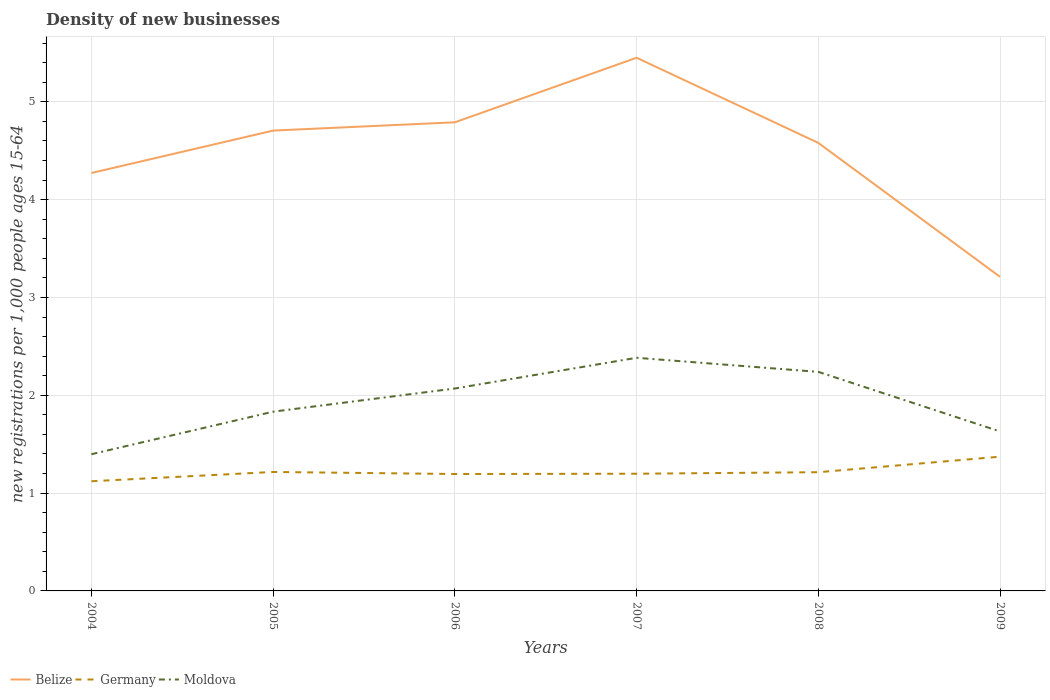Does the line corresponding to Belize intersect with the line corresponding to Moldova?
Your response must be concise. No. Across all years, what is the maximum number of new registrations in Germany?
Your response must be concise. 1.12. What is the total number of new registrations in Moldova in the graph?
Keep it short and to the point. -0.23. What is the difference between the highest and the second highest number of new registrations in Germany?
Offer a terse response. 0.25. Is the number of new registrations in Germany strictly greater than the number of new registrations in Belize over the years?
Your answer should be compact. Yes. How many lines are there?
Offer a very short reply. 3. How many years are there in the graph?
Provide a succinct answer. 6. What is the difference between two consecutive major ticks on the Y-axis?
Offer a very short reply. 1. Does the graph contain grids?
Make the answer very short. Yes. Where does the legend appear in the graph?
Provide a short and direct response. Bottom left. How many legend labels are there?
Your answer should be compact. 3. What is the title of the graph?
Give a very brief answer. Density of new businesses. Does "Mongolia" appear as one of the legend labels in the graph?
Provide a succinct answer. No. What is the label or title of the X-axis?
Your answer should be compact. Years. What is the label or title of the Y-axis?
Give a very brief answer. New registrations per 1,0 people ages 15-64. What is the new registrations per 1,000 people ages 15-64 of Belize in 2004?
Your response must be concise. 4.27. What is the new registrations per 1,000 people ages 15-64 in Germany in 2004?
Your answer should be compact. 1.12. What is the new registrations per 1,000 people ages 15-64 in Moldova in 2004?
Offer a terse response. 1.4. What is the new registrations per 1,000 people ages 15-64 of Belize in 2005?
Your response must be concise. 4.71. What is the new registrations per 1,000 people ages 15-64 of Germany in 2005?
Provide a short and direct response. 1.22. What is the new registrations per 1,000 people ages 15-64 of Moldova in 2005?
Offer a very short reply. 1.83. What is the new registrations per 1,000 people ages 15-64 of Belize in 2006?
Offer a very short reply. 4.79. What is the new registrations per 1,000 people ages 15-64 in Germany in 2006?
Your response must be concise. 1.2. What is the new registrations per 1,000 people ages 15-64 in Moldova in 2006?
Ensure brevity in your answer.  2.07. What is the new registrations per 1,000 people ages 15-64 of Belize in 2007?
Provide a succinct answer. 5.45. What is the new registrations per 1,000 people ages 15-64 of Germany in 2007?
Offer a terse response. 1.2. What is the new registrations per 1,000 people ages 15-64 in Moldova in 2007?
Provide a short and direct response. 2.38. What is the new registrations per 1,000 people ages 15-64 in Belize in 2008?
Ensure brevity in your answer.  4.58. What is the new registrations per 1,000 people ages 15-64 of Germany in 2008?
Give a very brief answer. 1.21. What is the new registrations per 1,000 people ages 15-64 of Moldova in 2008?
Your answer should be very brief. 2.24. What is the new registrations per 1,000 people ages 15-64 in Belize in 2009?
Your answer should be compact. 3.21. What is the new registrations per 1,000 people ages 15-64 in Germany in 2009?
Provide a succinct answer. 1.37. What is the new registrations per 1,000 people ages 15-64 of Moldova in 2009?
Your answer should be compact. 1.63. Across all years, what is the maximum new registrations per 1,000 people ages 15-64 of Belize?
Your answer should be compact. 5.45. Across all years, what is the maximum new registrations per 1,000 people ages 15-64 in Germany?
Make the answer very short. 1.37. Across all years, what is the maximum new registrations per 1,000 people ages 15-64 of Moldova?
Give a very brief answer. 2.38. Across all years, what is the minimum new registrations per 1,000 people ages 15-64 of Belize?
Make the answer very short. 3.21. Across all years, what is the minimum new registrations per 1,000 people ages 15-64 in Germany?
Ensure brevity in your answer.  1.12. Across all years, what is the minimum new registrations per 1,000 people ages 15-64 of Moldova?
Your answer should be very brief. 1.4. What is the total new registrations per 1,000 people ages 15-64 of Belize in the graph?
Keep it short and to the point. 27.01. What is the total new registrations per 1,000 people ages 15-64 of Germany in the graph?
Your answer should be very brief. 7.32. What is the total new registrations per 1,000 people ages 15-64 of Moldova in the graph?
Ensure brevity in your answer.  11.55. What is the difference between the new registrations per 1,000 people ages 15-64 of Belize in 2004 and that in 2005?
Keep it short and to the point. -0.43. What is the difference between the new registrations per 1,000 people ages 15-64 of Germany in 2004 and that in 2005?
Provide a succinct answer. -0.09. What is the difference between the new registrations per 1,000 people ages 15-64 of Moldova in 2004 and that in 2005?
Your response must be concise. -0.43. What is the difference between the new registrations per 1,000 people ages 15-64 of Belize in 2004 and that in 2006?
Give a very brief answer. -0.52. What is the difference between the new registrations per 1,000 people ages 15-64 of Germany in 2004 and that in 2006?
Give a very brief answer. -0.07. What is the difference between the new registrations per 1,000 people ages 15-64 in Moldova in 2004 and that in 2006?
Ensure brevity in your answer.  -0.67. What is the difference between the new registrations per 1,000 people ages 15-64 of Belize in 2004 and that in 2007?
Ensure brevity in your answer.  -1.18. What is the difference between the new registrations per 1,000 people ages 15-64 in Germany in 2004 and that in 2007?
Offer a very short reply. -0.08. What is the difference between the new registrations per 1,000 people ages 15-64 of Moldova in 2004 and that in 2007?
Your answer should be very brief. -0.99. What is the difference between the new registrations per 1,000 people ages 15-64 of Belize in 2004 and that in 2008?
Your answer should be very brief. -0.31. What is the difference between the new registrations per 1,000 people ages 15-64 of Germany in 2004 and that in 2008?
Your answer should be compact. -0.09. What is the difference between the new registrations per 1,000 people ages 15-64 in Moldova in 2004 and that in 2008?
Provide a succinct answer. -0.84. What is the difference between the new registrations per 1,000 people ages 15-64 of Belize in 2004 and that in 2009?
Give a very brief answer. 1.06. What is the difference between the new registrations per 1,000 people ages 15-64 in Germany in 2004 and that in 2009?
Give a very brief answer. -0.25. What is the difference between the new registrations per 1,000 people ages 15-64 in Moldova in 2004 and that in 2009?
Offer a very short reply. -0.23. What is the difference between the new registrations per 1,000 people ages 15-64 of Belize in 2005 and that in 2006?
Provide a succinct answer. -0.08. What is the difference between the new registrations per 1,000 people ages 15-64 in Germany in 2005 and that in 2006?
Provide a succinct answer. 0.02. What is the difference between the new registrations per 1,000 people ages 15-64 of Moldova in 2005 and that in 2006?
Your answer should be very brief. -0.24. What is the difference between the new registrations per 1,000 people ages 15-64 in Belize in 2005 and that in 2007?
Give a very brief answer. -0.74. What is the difference between the new registrations per 1,000 people ages 15-64 in Germany in 2005 and that in 2007?
Offer a very short reply. 0.02. What is the difference between the new registrations per 1,000 people ages 15-64 in Moldova in 2005 and that in 2007?
Ensure brevity in your answer.  -0.55. What is the difference between the new registrations per 1,000 people ages 15-64 of Belize in 2005 and that in 2008?
Provide a succinct answer. 0.13. What is the difference between the new registrations per 1,000 people ages 15-64 in Germany in 2005 and that in 2008?
Your answer should be compact. 0. What is the difference between the new registrations per 1,000 people ages 15-64 of Moldova in 2005 and that in 2008?
Provide a succinct answer. -0.41. What is the difference between the new registrations per 1,000 people ages 15-64 of Belize in 2005 and that in 2009?
Offer a very short reply. 1.5. What is the difference between the new registrations per 1,000 people ages 15-64 of Germany in 2005 and that in 2009?
Keep it short and to the point. -0.16. What is the difference between the new registrations per 1,000 people ages 15-64 of Moldova in 2005 and that in 2009?
Your answer should be compact. 0.2. What is the difference between the new registrations per 1,000 people ages 15-64 in Belize in 2006 and that in 2007?
Keep it short and to the point. -0.66. What is the difference between the new registrations per 1,000 people ages 15-64 in Germany in 2006 and that in 2007?
Your response must be concise. -0. What is the difference between the new registrations per 1,000 people ages 15-64 of Moldova in 2006 and that in 2007?
Keep it short and to the point. -0.31. What is the difference between the new registrations per 1,000 people ages 15-64 in Belize in 2006 and that in 2008?
Your response must be concise. 0.21. What is the difference between the new registrations per 1,000 people ages 15-64 of Germany in 2006 and that in 2008?
Your answer should be compact. -0.02. What is the difference between the new registrations per 1,000 people ages 15-64 in Moldova in 2006 and that in 2008?
Offer a terse response. -0.17. What is the difference between the new registrations per 1,000 people ages 15-64 in Belize in 2006 and that in 2009?
Ensure brevity in your answer.  1.58. What is the difference between the new registrations per 1,000 people ages 15-64 of Germany in 2006 and that in 2009?
Offer a terse response. -0.18. What is the difference between the new registrations per 1,000 people ages 15-64 in Moldova in 2006 and that in 2009?
Provide a succinct answer. 0.44. What is the difference between the new registrations per 1,000 people ages 15-64 of Belize in 2007 and that in 2008?
Ensure brevity in your answer.  0.87. What is the difference between the new registrations per 1,000 people ages 15-64 of Germany in 2007 and that in 2008?
Provide a short and direct response. -0.02. What is the difference between the new registrations per 1,000 people ages 15-64 of Moldova in 2007 and that in 2008?
Ensure brevity in your answer.  0.14. What is the difference between the new registrations per 1,000 people ages 15-64 of Belize in 2007 and that in 2009?
Your answer should be compact. 2.24. What is the difference between the new registrations per 1,000 people ages 15-64 in Germany in 2007 and that in 2009?
Give a very brief answer. -0.17. What is the difference between the new registrations per 1,000 people ages 15-64 in Moldova in 2007 and that in 2009?
Your answer should be compact. 0.75. What is the difference between the new registrations per 1,000 people ages 15-64 in Belize in 2008 and that in 2009?
Give a very brief answer. 1.37. What is the difference between the new registrations per 1,000 people ages 15-64 of Germany in 2008 and that in 2009?
Your answer should be compact. -0.16. What is the difference between the new registrations per 1,000 people ages 15-64 in Moldova in 2008 and that in 2009?
Provide a succinct answer. 0.61. What is the difference between the new registrations per 1,000 people ages 15-64 in Belize in 2004 and the new registrations per 1,000 people ages 15-64 in Germany in 2005?
Your response must be concise. 3.06. What is the difference between the new registrations per 1,000 people ages 15-64 in Belize in 2004 and the new registrations per 1,000 people ages 15-64 in Moldova in 2005?
Offer a very short reply. 2.44. What is the difference between the new registrations per 1,000 people ages 15-64 of Germany in 2004 and the new registrations per 1,000 people ages 15-64 of Moldova in 2005?
Your answer should be compact. -0.71. What is the difference between the new registrations per 1,000 people ages 15-64 in Belize in 2004 and the new registrations per 1,000 people ages 15-64 in Germany in 2006?
Your answer should be compact. 3.08. What is the difference between the new registrations per 1,000 people ages 15-64 of Belize in 2004 and the new registrations per 1,000 people ages 15-64 of Moldova in 2006?
Your answer should be very brief. 2.2. What is the difference between the new registrations per 1,000 people ages 15-64 in Germany in 2004 and the new registrations per 1,000 people ages 15-64 in Moldova in 2006?
Give a very brief answer. -0.95. What is the difference between the new registrations per 1,000 people ages 15-64 in Belize in 2004 and the new registrations per 1,000 people ages 15-64 in Germany in 2007?
Give a very brief answer. 3.07. What is the difference between the new registrations per 1,000 people ages 15-64 in Belize in 2004 and the new registrations per 1,000 people ages 15-64 in Moldova in 2007?
Provide a succinct answer. 1.89. What is the difference between the new registrations per 1,000 people ages 15-64 in Germany in 2004 and the new registrations per 1,000 people ages 15-64 in Moldova in 2007?
Offer a terse response. -1.26. What is the difference between the new registrations per 1,000 people ages 15-64 of Belize in 2004 and the new registrations per 1,000 people ages 15-64 of Germany in 2008?
Your answer should be compact. 3.06. What is the difference between the new registrations per 1,000 people ages 15-64 in Belize in 2004 and the new registrations per 1,000 people ages 15-64 in Moldova in 2008?
Make the answer very short. 2.03. What is the difference between the new registrations per 1,000 people ages 15-64 in Germany in 2004 and the new registrations per 1,000 people ages 15-64 in Moldova in 2008?
Your answer should be very brief. -1.12. What is the difference between the new registrations per 1,000 people ages 15-64 of Belize in 2004 and the new registrations per 1,000 people ages 15-64 of Germany in 2009?
Offer a very short reply. 2.9. What is the difference between the new registrations per 1,000 people ages 15-64 of Belize in 2004 and the new registrations per 1,000 people ages 15-64 of Moldova in 2009?
Give a very brief answer. 2.64. What is the difference between the new registrations per 1,000 people ages 15-64 of Germany in 2004 and the new registrations per 1,000 people ages 15-64 of Moldova in 2009?
Keep it short and to the point. -0.51. What is the difference between the new registrations per 1,000 people ages 15-64 in Belize in 2005 and the new registrations per 1,000 people ages 15-64 in Germany in 2006?
Give a very brief answer. 3.51. What is the difference between the new registrations per 1,000 people ages 15-64 of Belize in 2005 and the new registrations per 1,000 people ages 15-64 of Moldova in 2006?
Your answer should be very brief. 2.64. What is the difference between the new registrations per 1,000 people ages 15-64 of Germany in 2005 and the new registrations per 1,000 people ages 15-64 of Moldova in 2006?
Ensure brevity in your answer.  -0.85. What is the difference between the new registrations per 1,000 people ages 15-64 in Belize in 2005 and the new registrations per 1,000 people ages 15-64 in Germany in 2007?
Give a very brief answer. 3.51. What is the difference between the new registrations per 1,000 people ages 15-64 of Belize in 2005 and the new registrations per 1,000 people ages 15-64 of Moldova in 2007?
Give a very brief answer. 2.32. What is the difference between the new registrations per 1,000 people ages 15-64 of Germany in 2005 and the new registrations per 1,000 people ages 15-64 of Moldova in 2007?
Provide a short and direct response. -1.17. What is the difference between the new registrations per 1,000 people ages 15-64 in Belize in 2005 and the new registrations per 1,000 people ages 15-64 in Germany in 2008?
Give a very brief answer. 3.49. What is the difference between the new registrations per 1,000 people ages 15-64 in Belize in 2005 and the new registrations per 1,000 people ages 15-64 in Moldova in 2008?
Provide a short and direct response. 2.47. What is the difference between the new registrations per 1,000 people ages 15-64 of Germany in 2005 and the new registrations per 1,000 people ages 15-64 of Moldova in 2008?
Keep it short and to the point. -1.02. What is the difference between the new registrations per 1,000 people ages 15-64 in Belize in 2005 and the new registrations per 1,000 people ages 15-64 in Germany in 2009?
Provide a succinct answer. 3.33. What is the difference between the new registrations per 1,000 people ages 15-64 in Belize in 2005 and the new registrations per 1,000 people ages 15-64 in Moldova in 2009?
Provide a short and direct response. 3.08. What is the difference between the new registrations per 1,000 people ages 15-64 of Germany in 2005 and the new registrations per 1,000 people ages 15-64 of Moldova in 2009?
Provide a short and direct response. -0.41. What is the difference between the new registrations per 1,000 people ages 15-64 in Belize in 2006 and the new registrations per 1,000 people ages 15-64 in Germany in 2007?
Your response must be concise. 3.59. What is the difference between the new registrations per 1,000 people ages 15-64 in Belize in 2006 and the new registrations per 1,000 people ages 15-64 in Moldova in 2007?
Give a very brief answer. 2.41. What is the difference between the new registrations per 1,000 people ages 15-64 of Germany in 2006 and the new registrations per 1,000 people ages 15-64 of Moldova in 2007?
Your response must be concise. -1.19. What is the difference between the new registrations per 1,000 people ages 15-64 in Belize in 2006 and the new registrations per 1,000 people ages 15-64 in Germany in 2008?
Your response must be concise. 3.58. What is the difference between the new registrations per 1,000 people ages 15-64 of Belize in 2006 and the new registrations per 1,000 people ages 15-64 of Moldova in 2008?
Your answer should be compact. 2.55. What is the difference between the new registrations per 1,000 people ages 15-64 of Germany in 2006 and the new registrations per 1,000 people ages 15-64 of Moldova in 2008?
Your answer should be very brief. -1.04. What is the difference between the new registrations per 1,000 people ages 15-64 of Belize in 2006 and the new registrations per 1,000 people ages 15-64 of Germany in 2009?
Your answer should be compact. 3.42. What is the difference between the new registrations per 1,000 people ages 15-64 in Belize in 2006 and the new registrations per 1,000 people ages 15-64 in Moldova in 2009?
Your answer should be very brief. 3.16. What is the difference between the new registrations per 1,000 people ages 15-64 in Germany in 2006 and the new registrations per 1,000 people ages 15-64 in Moldova in 2009?
Offer a very short reply. -0.43. What is the difference between the new registrations per 1,000 people ages 15-64 of Belize in 2007 and the new registrations per 1,000 people ages 15-64 of Germany in 2008?
Offer a very short reply. 4.24. What is the difference between the new registrations per 1,000 people ages 15-64 in Belize in 2007 and the new registrations per 1,000 people ages 15-64 in Moldova in 2008?
Give a very brief answer. 3.21. What is the difference between the new registrations per 1,000 people ages 15-64 in Germany in 2007 and the new registrations per 1,000 people ages 15-64 in Moldova in 2008?
Make the answer very short. -1.04. What is the difference between the new registrations per 1,000 people ages 15-64 of Belize in 2007 and the new registrations per 1,000 people ages 15-64 of Germany in 2009?
Provide a short and direct response. 4.08. What is the difference between the new registrations per 1,000 people ages 15-64 of Belize in 2007 and the new registrations per 1,000 people ages 15-64 of Moldova in 2009?
Your answer should be compact. 3.82. What is the difference between the new registrations per 1,000 people ages 15-64 in Germany in 2007 and the new registrations per 1,000 people ages 15-64 in Moldova in 2009?
Provide a succinct answer. -0.43. What is the difference between the new registrations per 1,000 people ages 15-64 of Belize in 2008 and the new registrations per 1,000 people ages 15-64 of Germany in 2009?
Make the answer very short. 3.21. What is the difference between the new registrations per 1,000 people ages 15-64 in Belize in 2008 and the new registrations per 1,000 people ages 15-64 in Moldova in 2009?
Give a very brief answer. 2.95. What is the difference between the new registrations per 1,000 people ages 15-64 of Germany in 2008 and the new registrations per 1,000 people ages 15-64 of Moldova in 2009?
Keep it short and to the point. -0.42. What is the average new registrations per 1,000 people ages 15-64 of Belize per year?
Your answer should be very brief. 4.5. What is the average new registrations per 1,000 people ages 15-64 in Germany per year?
Ensure brevity in your answer.  1.22. What is the average new registrations per 1,000 people ages 15-64 in Moldova per year?
Your response must be concise. 1.93. In the year 2004, what is the difference between the new registrations per 1,000 people ages 15-64 of Belize and new registrations per 1,000 people ages 15-64 of Germany?
Offer a terse response. 3.15. In the year 2004, what is the difference between the new registrations per 1,000 people ages 15-64 in Belize and new registrations per 1,000 people ages 15-64 in Moldova?
Offer a very short reply. 2.87. In the year 2004, what is the difference between the new registrations per 1,000 people ages 15-64 of Germany and new registrations per 1,000 people ages 15-64 of Moldova?
Ensure brevity in your answer.  -0.28. In the year 2005, what is the difference between the new registrations per 1,000 people ages 15-64 in Belize and new registrations per 1,000 people ages 15-64 in Germany?
Your answer should be compact. 3.49. In the year 2005, what is the difference between the new registrations per 1,000 people ages 15-64 in Belize and new registrations per 1,000 people ages 15-64 in Moldova?
Offer a terse response. 2.87. In the year 2005, what is the difference between the new registrations per 1,000 people ages 15-64 in Germany and new registrations per 1,000 people ages 15-64 in Moldova?
Offer a terse response. -0.62. In the year 2006, what is the difference between the new registrations per 1,000 people ages 15-64 in Belize and new registrations per 1,000 people ages 15-64 in Germany?
Keep it short and to the point. 3.6. In the year 2006, what is the difference between the new registrations per 1,000 people ages 15-64 of Belize and new registrations per 1,000 people ages 15-64 of Moldova?
Provide a short and direct response. 2.72. In the year 2006, what is the difference between the new registrations per 1,000 people ages 15-64 of Germany and new registrations per 1,000 people ages 15-64 of Moldova?
Your response must be concise. -0.87. In the year 2007, what is the difference between the new registrations per 1,000 people ages 15-64 in Belize and new registrations per 1,000 people ages 15-64 in Germany?
Provide a short and direct response. 4.25. In the year 2007, what is the difference between the new registrations per 1,000 people ages 15-64 of Belize and new registrations per 1,000 people ages 15-64 of Moldova?
Your answer should be very brief. 3.07. In the year 2007, what is the difference between the new registrations per 1,000 people ages 15-64 in Germany and new registrations per 1,000 people ages 15-64 in Moldova?
Provide a short and direct response. -1.19. In the year 2008, what is the difference between the new registrations per 1,000 people ages 15-64 in Belize and new registrations per 1,000 people ages 15-64 in Germany?
Your response must be concise. 3.37. In the year 2008, what is the difference between the new registrations per 1,000 people ages 15-64 of Belize and new registrations per 1,000 people ages 15-64 of Moldova?
Your answer should be compact. 2.34. In the year 2008, what is the difference between the new registrations per 1,000 people ages 15-64 of Germany and new registrations per 1,000 people ages 15-64 of Moldova?
Give a very brief answer. -1.03. In the year 2009, what is the difference between the new registrations per 1,000 people ages 15-64 of Belize and new registrations per 1,000 people ages 15-64 of Germany?
Provide a succinct answer. 1.84. In the year 2009, what is the difference between the new registrations per 1,000 people ages 15-64 of Belize and new registrations per 1,000 people ages 15-64 of Moldova?
Your response must be concise. 1.58. In the year 2009, what is the difference between the new registrations per 1,000 people ages 15-64 of Germany and new registrations per 1,000 people ages 15-64 of Moldova?
Make the answer very short. -0.26. What is the ratio of the new registrations per 1,000 people ages 15-64 in Belize in 2004 to that in 2005?
Ensure brevity in your answer.  0.91. What is the ratio of the new registrations per 1,000 people ages 15-64 of Germany in 2004 to that in 2005?
Your response must be concise. 0.92. What is the ratio of the new registrations per 1,000 people ages 15-64 in Moldova in 2004 to that in 2005?
Offer a terse response. 0.76. What is the ratio of the new registrations per 1,000 people ages 15-64 of Belize in 2004 to that in 2006?
Provide a succinct answer. 0.89. What is the ratio of the new registrations per 1,000 people ages 15-64 of Germany in 2004 to that in 2006?
Offer a terse response. 0.94. What is the ratio of the new registrations per 1,000 people ages 15-64 in Moldova in 2004 to that in 2006?
Offer a very short reply. 0.68. What is the ratio of the new registrations per 1,000 people ages 15-64 in Belize in 2004 to that in 2007?
Provide a short and direct response. 0.78. What is the ratio of the new registrations per 1,000 people ages 15-64 in Germany in 2004 to that in 2007?
Offer a terse response. 0.94. What is the ratio of the new registrations per 1,000 people ages 15-64 in Moldova in 2004 to that in 2007?
Ensure brevity in your answer.  0.59. What is the ratio of the new registrations per 1,000 people ages 15-64 of Belize in 2004 to that in 2008?
Provide a short and direct response. 0.93. What is the ratio of the new registrations per 1,000 people ages 15-64 in Germany in 2004 to that in 2008?
Your answer should be very brief. 0.92. What is the ratio of the new registrations per 1,000 people ages 15-64 in Moldova in 2004 to that in 2008?
Your answer should be compact. 0.62. What is the ratio of the new registrations per 1,000 people ages 15-64 in Belize in 2004 to that in 2009?
Offer a very short reply. 1.33. What is the ratio of the new registrations per 1,000 people ages 15-64 of Germany in 2004 to that in 2009?
Provide a succinct answer. 0.82. What is the ratio of the new registrations per 1,000 people ages 15-64 of Moldova in 2004 to that in 2009?
Your response must be concise. 0.86. What is the ratio of the new registrations per 1,000 people ages 15-64 in Belize in 2005 to that in 2006?
Offer a very short reply. 0.98. What is the ratio of the new registrations per 1,000 people ages 15-64 of Germany in 2005 to that in 2006?
Provide a succinct answer. 1.02. What is the ratio of the new registrations per 1,000 people ages 15-64 of Moldova in 2005 to that in 2006?
Give a very brief answer. 0.89. What is the ratio of the new registrations per 1,000 people ages 15-64 of Belize in 2005 to that in 2007?
Provide a short and direct response. 0.86. What is the ratio of the new registrations per 1,000 people ages 15-64 in Germany in 2005 to that in 2007?
Provide a succinct answer. 1.01. What is the ratio of the new registrations per 1,000 people ages 15-64 in Moldova in 2005 to that in 2007?
Your response must be concise. 0.77. What is the ratio of the new registrations per 1,000 people ages 15-64 in Belize in 2005 to that in 2008?
Give a very brief answer. 1.03. What is the ratio of the new registrations per 1,000 people ages 15-64 of Germany in 2005 to that in 2008?
Your answer should be compact. 1. What is the ratio of the new registrations per 1,000 people ages 15-64 in Moldova in 2005 to that in 2008?
Ensure brevity in your answer.  0.82. What is the ratio of the new registrations per 1,000 people ages 15-64 of Belize in 2005 to that in 2009?
Provide a succinct answer. 1.47. What is the ratio of the new registrations per 1,000 people ages 15-64 of Germany in 2005 to that in 2009?
Keep it short and to the point. 0.89. What is the ratio of the new registrations per 1,000 people ages 15-64 in Moldova in 2005 to that in 2009?
Your answer should be compact. 1.12. What is the ratio of the new registrations per 1,000 people ages 15-64 in Belize in 2006 to that in 2007?
Your answer should be compact. 0.88. What is the ratio of the new registrations per 1,000 people ages 15-64 in Moldova in 2006 to that in 2007?
Provide a succinct answer. 0.87. What is the ratio of the new registrations per 1,000 people ages 15-64 in Belize in 2006 to that in 2008?
Your response must be concise. 1.05. What is the ratio of the new registrations per 1,000 people ages 15-64 in Germany in 2006 to that in 2008?
Your response must be concise. 0.98. What is the ratio of the new registrations per 1,000 people ages 15-64 in Moldova in 2006 to that in 2008?
Your answer should be very brief. 0.92. What is the ratio of the new registrations per 1,000 people ages 15-64 of Belize in 2006 to that in 2009?
Provide a short and direct response. 1.49. What is the ratio of the new registrations per 1,000 people ages 15-64 in Germany in 2006 to that in 2009?
Your answer should be very brief. 0.87. What is the ratio of the new registrations per 1,000 people ages 15-64 of Moldova in 2006 to that in 2009?
Your answer should be compact. 1.27. What is the ratio of the new registrations per 1,000 people ages 15-64 in Belize in 2007 to that in 2008?
Make the answer very short. 1.19. What is the ratio of the new registrations per 1,000 people ages 15-64 of Germany in 2007 to that in 2008?
Your response must be concise. 0.99. What is the ratio of the new registrations per 1,000 people ages 15-64 of Moldova in 2007 to that in 2008?
Provide a succinct answer. 1.06. What is the ratio of the new registrations per 1,000 people ages 15-64 in Belize in 2007 to that in 2009?
Your answer should be compact. 1.7. What is the ratio of the new registrations per 1,000 people ages 15-64 of Germany in 2007 to that in 2009?
Ensure brevity in your answer.  0.87. What is the ratio of the new registrations per 1,000 people ages 15-64 in Moldova in 2007 to that in 2009?
Make the answer very short. 1.46. What is the ratio of the new registrations per 1,000 people ages 15-64 in Belize in 2008 to that in 2009?
Provide a succinct answer. 1.43. What is the ratio of the new registrations per 1,000 people ages 15-64 of Germany in 2008 to that in 2009?
Ensure brevity in your answer.  0.88. What is the ratio of the new registrations per 1,000 people ages 15-64 in Moldova in 2008 to that in 2009?
Your answer should be very brief. 1.37. What is the difference between the highest and the second highest new registrations per 1,000 people ages 15-64 in Belize?
Your answer should be compact. 0.66. What is the difference between the highest and the second highest new registrations per 1,000 people ages 15-64 in Germany?
Offer a terse response. 0.16. What is the difference between the highest and the second highest new registrations per 1,000 people ages 15-64 of Moldova?
Your response must be concise. 0.14. What is the difference between the highest and the lowest new registrations per 1,000 people ages 15-64 in Belize?
Your answer should be very brief. 2.24. What is the difference between the highest and the lowest new registrations per 1,000 people ages 15-64 in Germany?
Provide a short and direct response. 0.25. What is the difference between the highest and the lowest new registrations per 1,000 people ages 15-64 in Moldova?
Give a very brief answer. 0.99. 